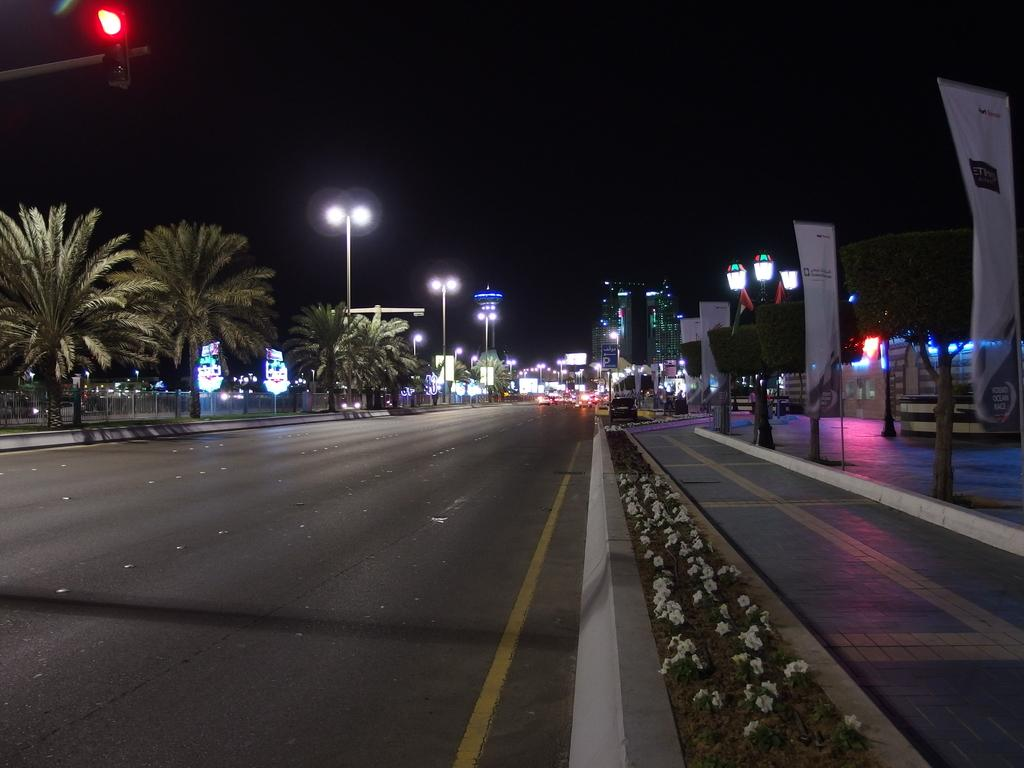What type of vegetation can be seen beside the road in the image? There are plants, flowers, and trees beside the road in the image. What structures are present beside the road? There is a fence, hoardings, and light poles beside the road. What can be seen in the distance from the road? There are buildings visible in the distance. What type of kettle is being used for pleasure in the image? There is no kettle or any indication of pleasure-related activities present in the image. 